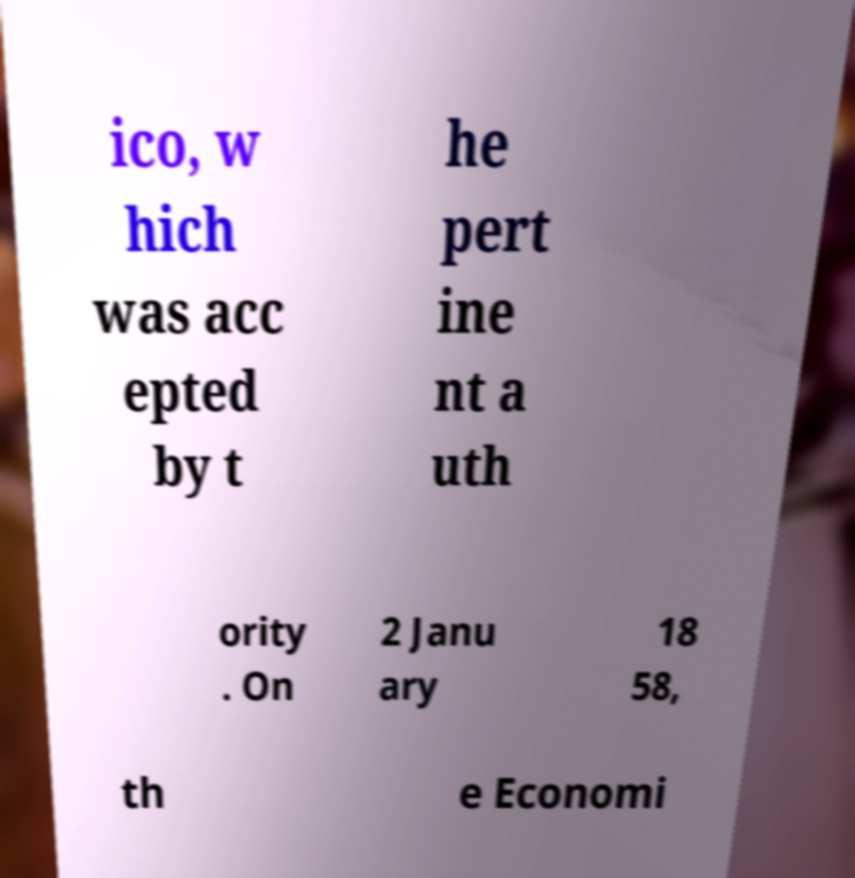Can you accurately transcribe the text from the provided image for me? ico, w hich was acc epted by t he pert ine nt a uth ority . On 2 Janu ary 18 58, th e Economi 